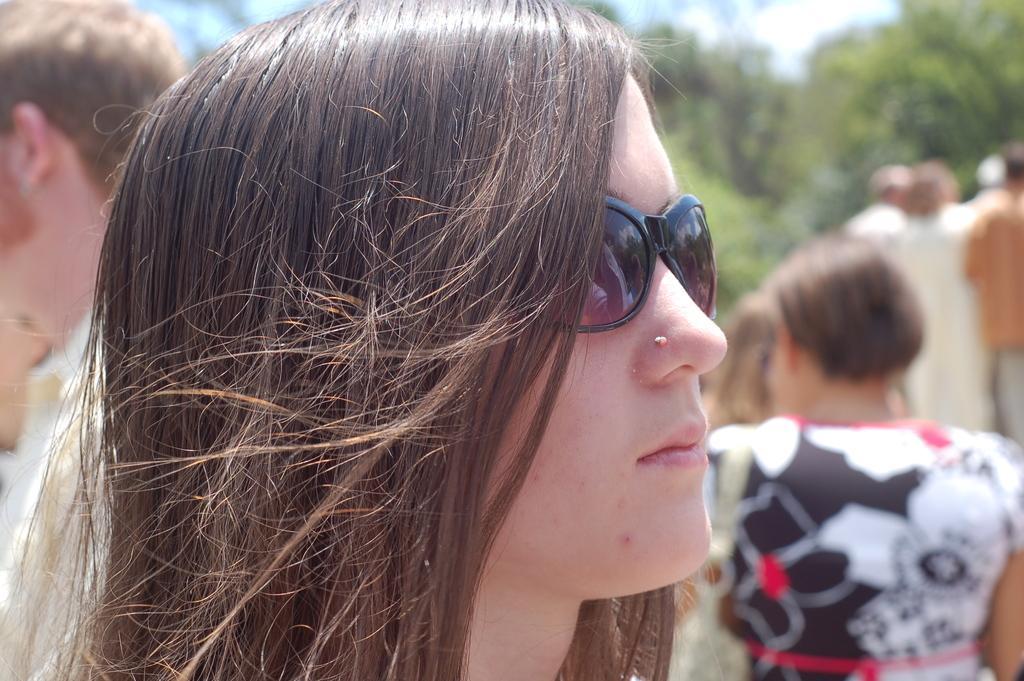Can you describe this image briefly? In this picture there is a woman with goggles is standing in the foreground. At the back there are group of people and there are trees. At the top there is sky. 